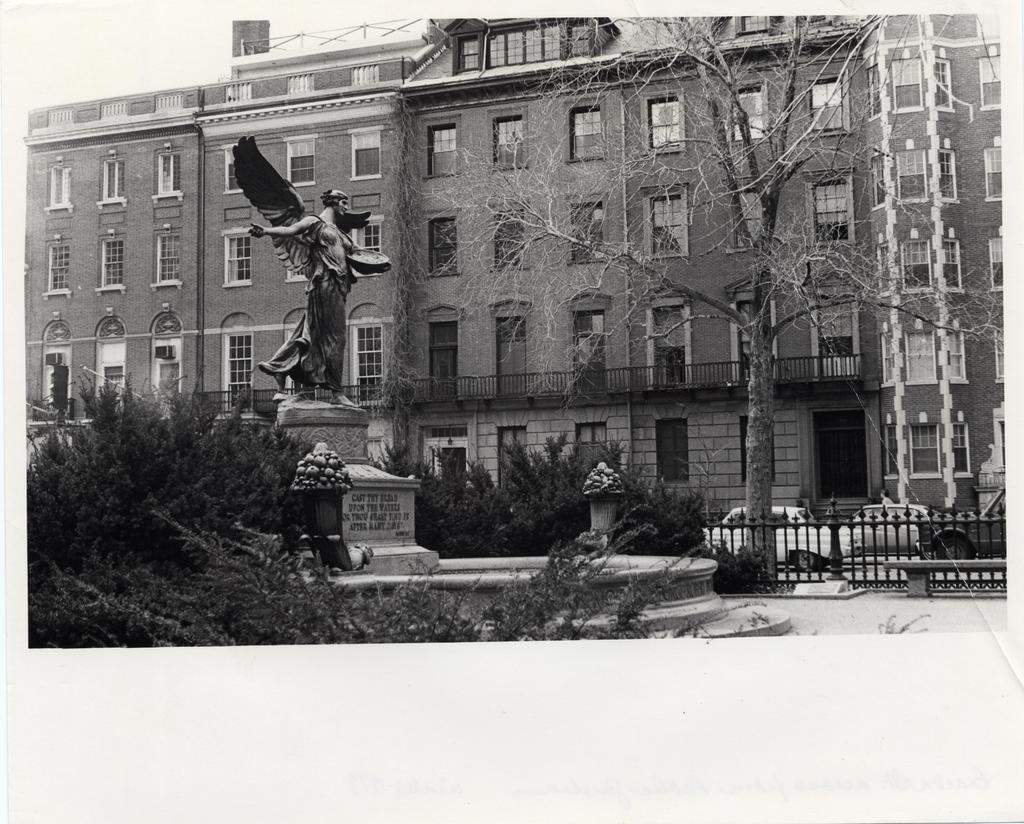What can be seen on the poster in the image? The content of the poster is not mentioned in the facts, so we cannot answer this question definitively. What type of structure is depicted with windows in the image? There is a building with windows in the image. What is the statue in the image representing? The facts do not provide information about the statue's representation, so we cannot answer this question definitively. What is written on the object with text in the image? The facts do not specify the content of the text, so we cannot answer this question definitively. What type of vegetation is present in the image? There are trees and plants in the image. What is visible on the ground in the image? The ground is visible in the image. What types of vehicles can be seen in the image? The facts do not specify the types of vehicles, so we cannot answer this question definitively. What is the purpose of the fencing in the image? The facts do not provide information about the purpose of the fencing, so we cannot answer this question definitively. What are the poles in the image used for? The facts do not specify the purpose of the poles, so we cannot answer this question definitively. How many pizzas are on the straw in the image? There is no straw or pizzas present in the image. What is the view like from the top of the building in the image? The facts do not provide information about the view from the building, so we cannot answer this question definitively. 